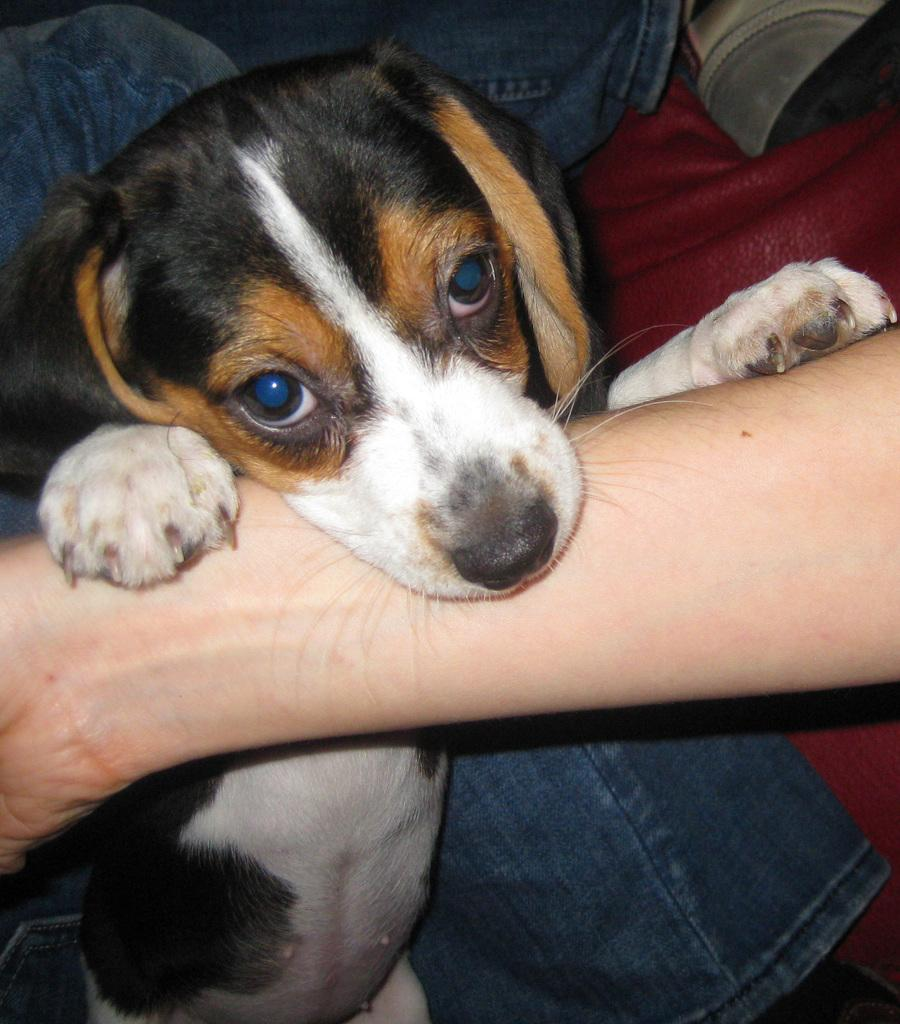What type of animal is in the image? There is a dog in the image. Can you describe any human interaction with the dog? A person's hand is visible in the image, suggesting some interaction with the dog. What object is present in the image that might provide comfort or warmth? There is a blanket in the image. What time does the clock show in the image? There is no clock present in the image, so it is not possible to determine the time. 